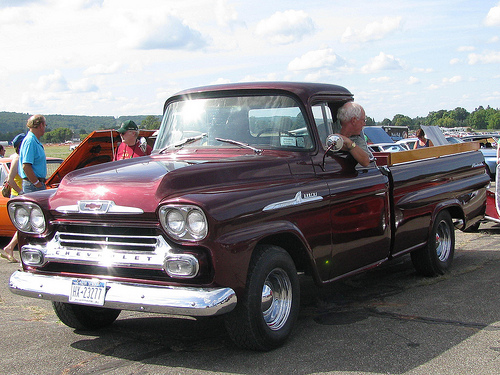<image>
Is the person behind the person? No. The person is not behind the person. From this viewpoint, the person appears to be positioned elsewhere in the scene. 